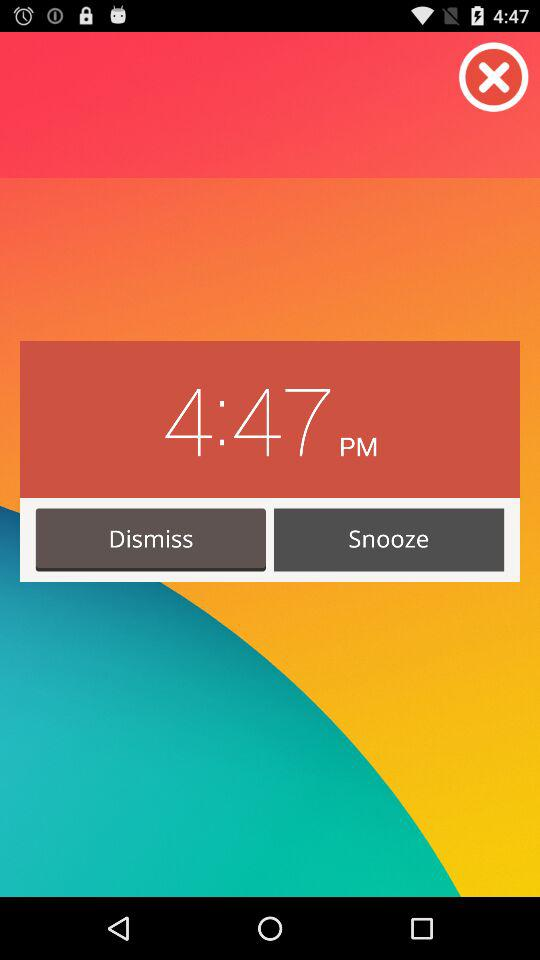What are the options that I can select for this alarm time? The options that you can select are "Dismiss" and "Snooze". 